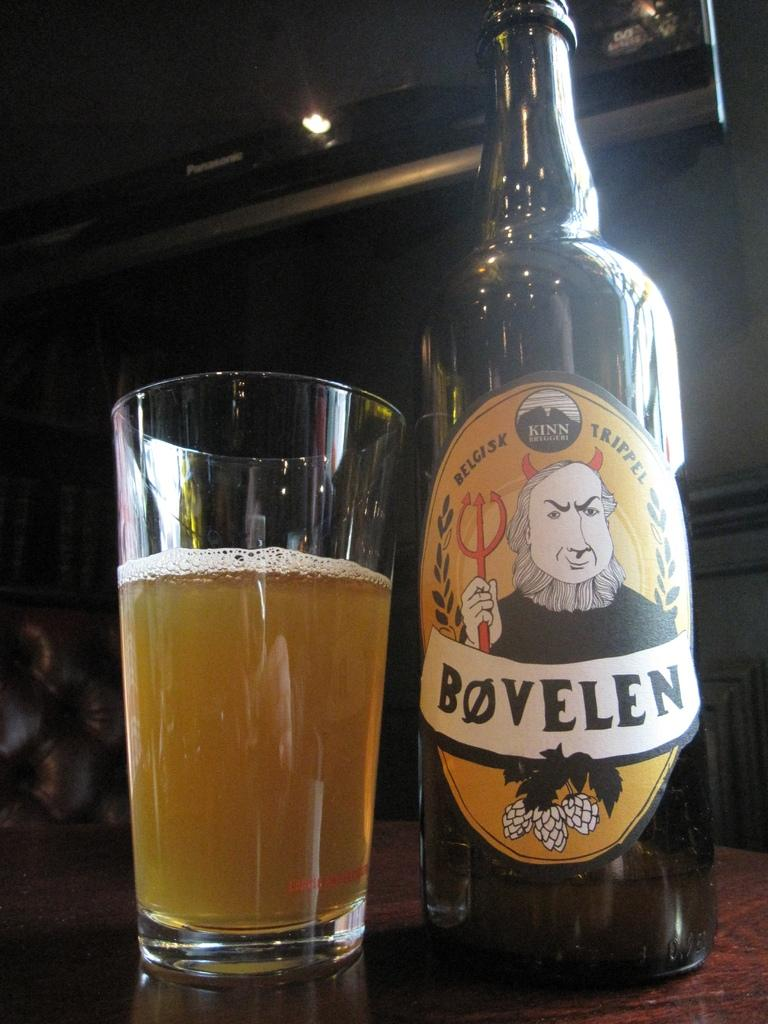<image>
Summarize the visual content of the image. Bovellen beer bottle next to a half full cup of beer. 